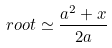Convert formula to latex. <formula><loc_0><loc_0><loc_500><loc_500>r o o t \simeq { \frac { a ^ { 2 } + x } { 2 a } } \,</formula> 